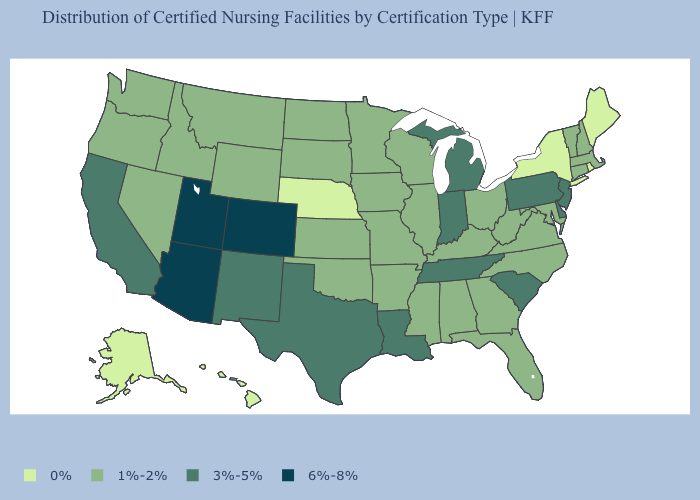Among the states that border Colorado , does Utah have the highest value?
Concise answer only. Yes. Among the states that border Delaware , does New Jersey have the lowest value?
Be succinct. No. Is the legend a continuous bar?
Write a very short answer. No. Which states have the lowest value in the MidWest?
Give a very brief answer. Nebraska. What is the highest value in the South ?
Answer briefly. 3%-5%. What is the highest value in the USA?
Give a very brief answer. 6%-8%. What is the value of Texas?
Concise answer only. 3%-5%. What is the lowest value in the MidWest?
Quick response, please. 0%. Does Indiana have the highest value in the MidWest?
Quick response, please. Yes. What is the value of New Hampshire?
Concise answer only. 1%-2%. What is the value of Wisconsin?
Be succinct. 1%-2%. What is the highest value in states that border North Carolina?
Concise answer only. 3%-5%. Name the states that have a value in the range 3%-5%?
Be succinct. California, Delaware, Indiana, Louisiana, Michigan, New Jersey, New Mexico, Pennsylvania, South Carolina, Tennessee, Texas. How many symbols are there in the legend?
Give a very brief answer. 4. What is the value of Maine?
Answer briefly. 0%. 